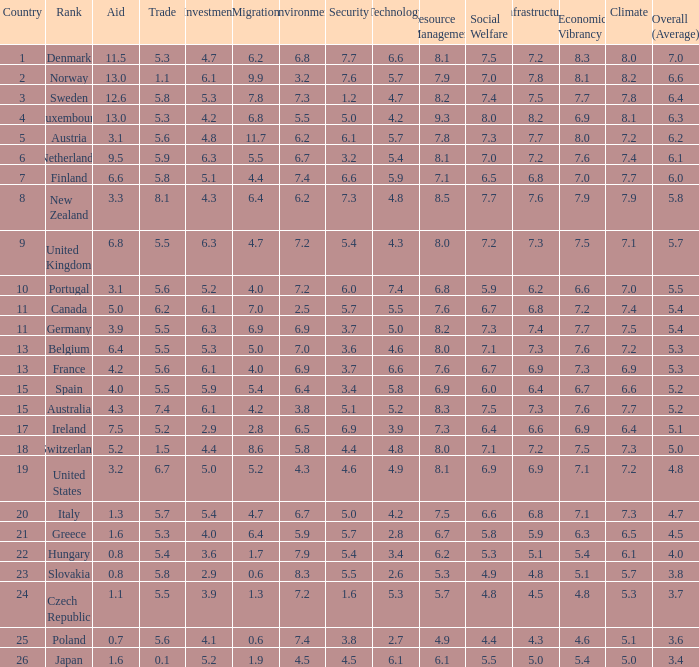What is the environment rating of the country with an overall average rating of 4.7? 6.7. 